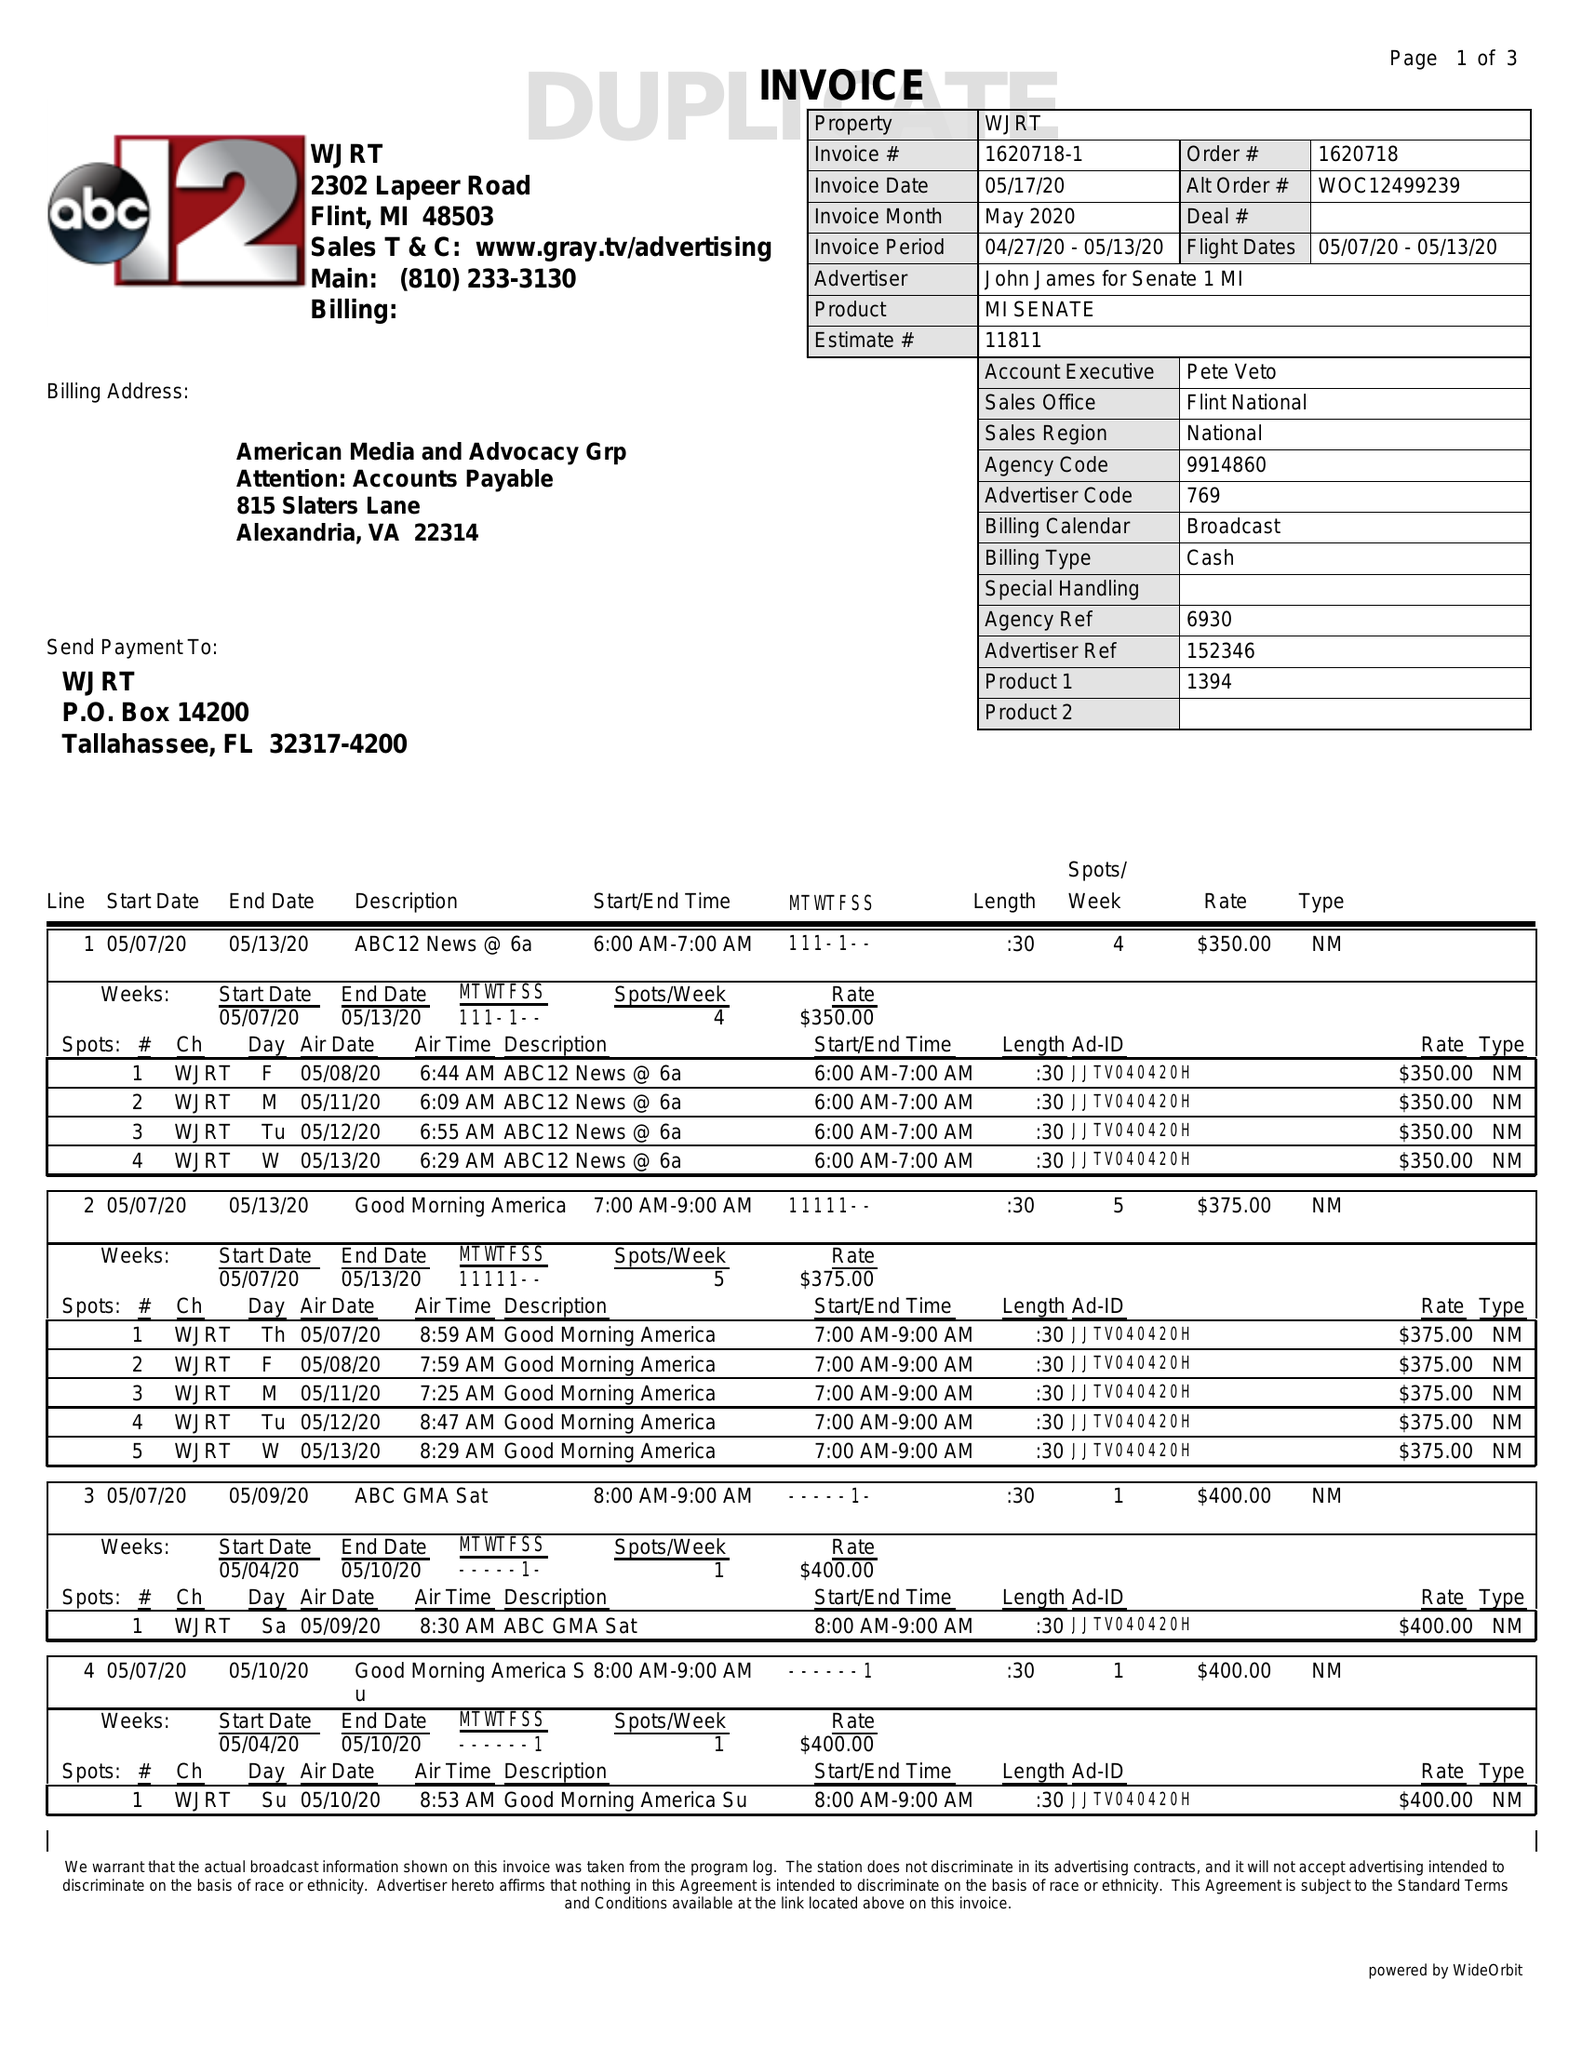What is the value for the flight_from?
Answer the question using a single word or phrase. 05/07/20 